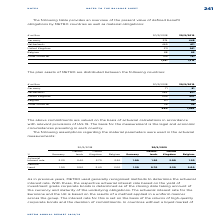According to Metro Ag's financial document, What is the valuation of the commitments in the table based on? valued on the basis of actuarial calculations in accordance with relevant provisions of IAS 19. The document states: "The above commitments are valued on the basis of actuarial calculations in accordance with relevant provisions of IAS 19. The basis for the measuremen..." Also, What is the basis for the measurements? Based on the financial document, the answer is the legal and economic circumstances prevailing in each country. Also, What are the countries in the table of which the plan assets of METRO are distributed in? The document contains multiple relevant values: Germany, Netherlands, United Kingdom, Belgium, Other countries. From the document: "Germany 71 81 Netherlands 584 671 Other countries 26 25 Belgium 50 52 United Kingdom 209 237..." Additionally, In which year was the amount for Belgium larger? According to the financial document, 2019. The relevant text states: "€ million 30/9/2018 30/9/2019..." Also, can you calculate: What was the change in the amount for Germany in FY2019 from FY2018? Based on the calculation: 81-71, the result is 10 (in millions). This is based on the information: "Germany 71 81 Germany 71 81..." The key data points involved are: 71, 81. Also, can you calculate: What was the percentage change in the amount for Germany in FY2019 from FY2018? To answer this question, I need to perform calculations using the financial data. The calculation is: (81-71)/71, which equals 14.08 (percentage). This is based on the information: "Germany 71 81 Germany 71 81..." The key data points involved are: 71, 81. 